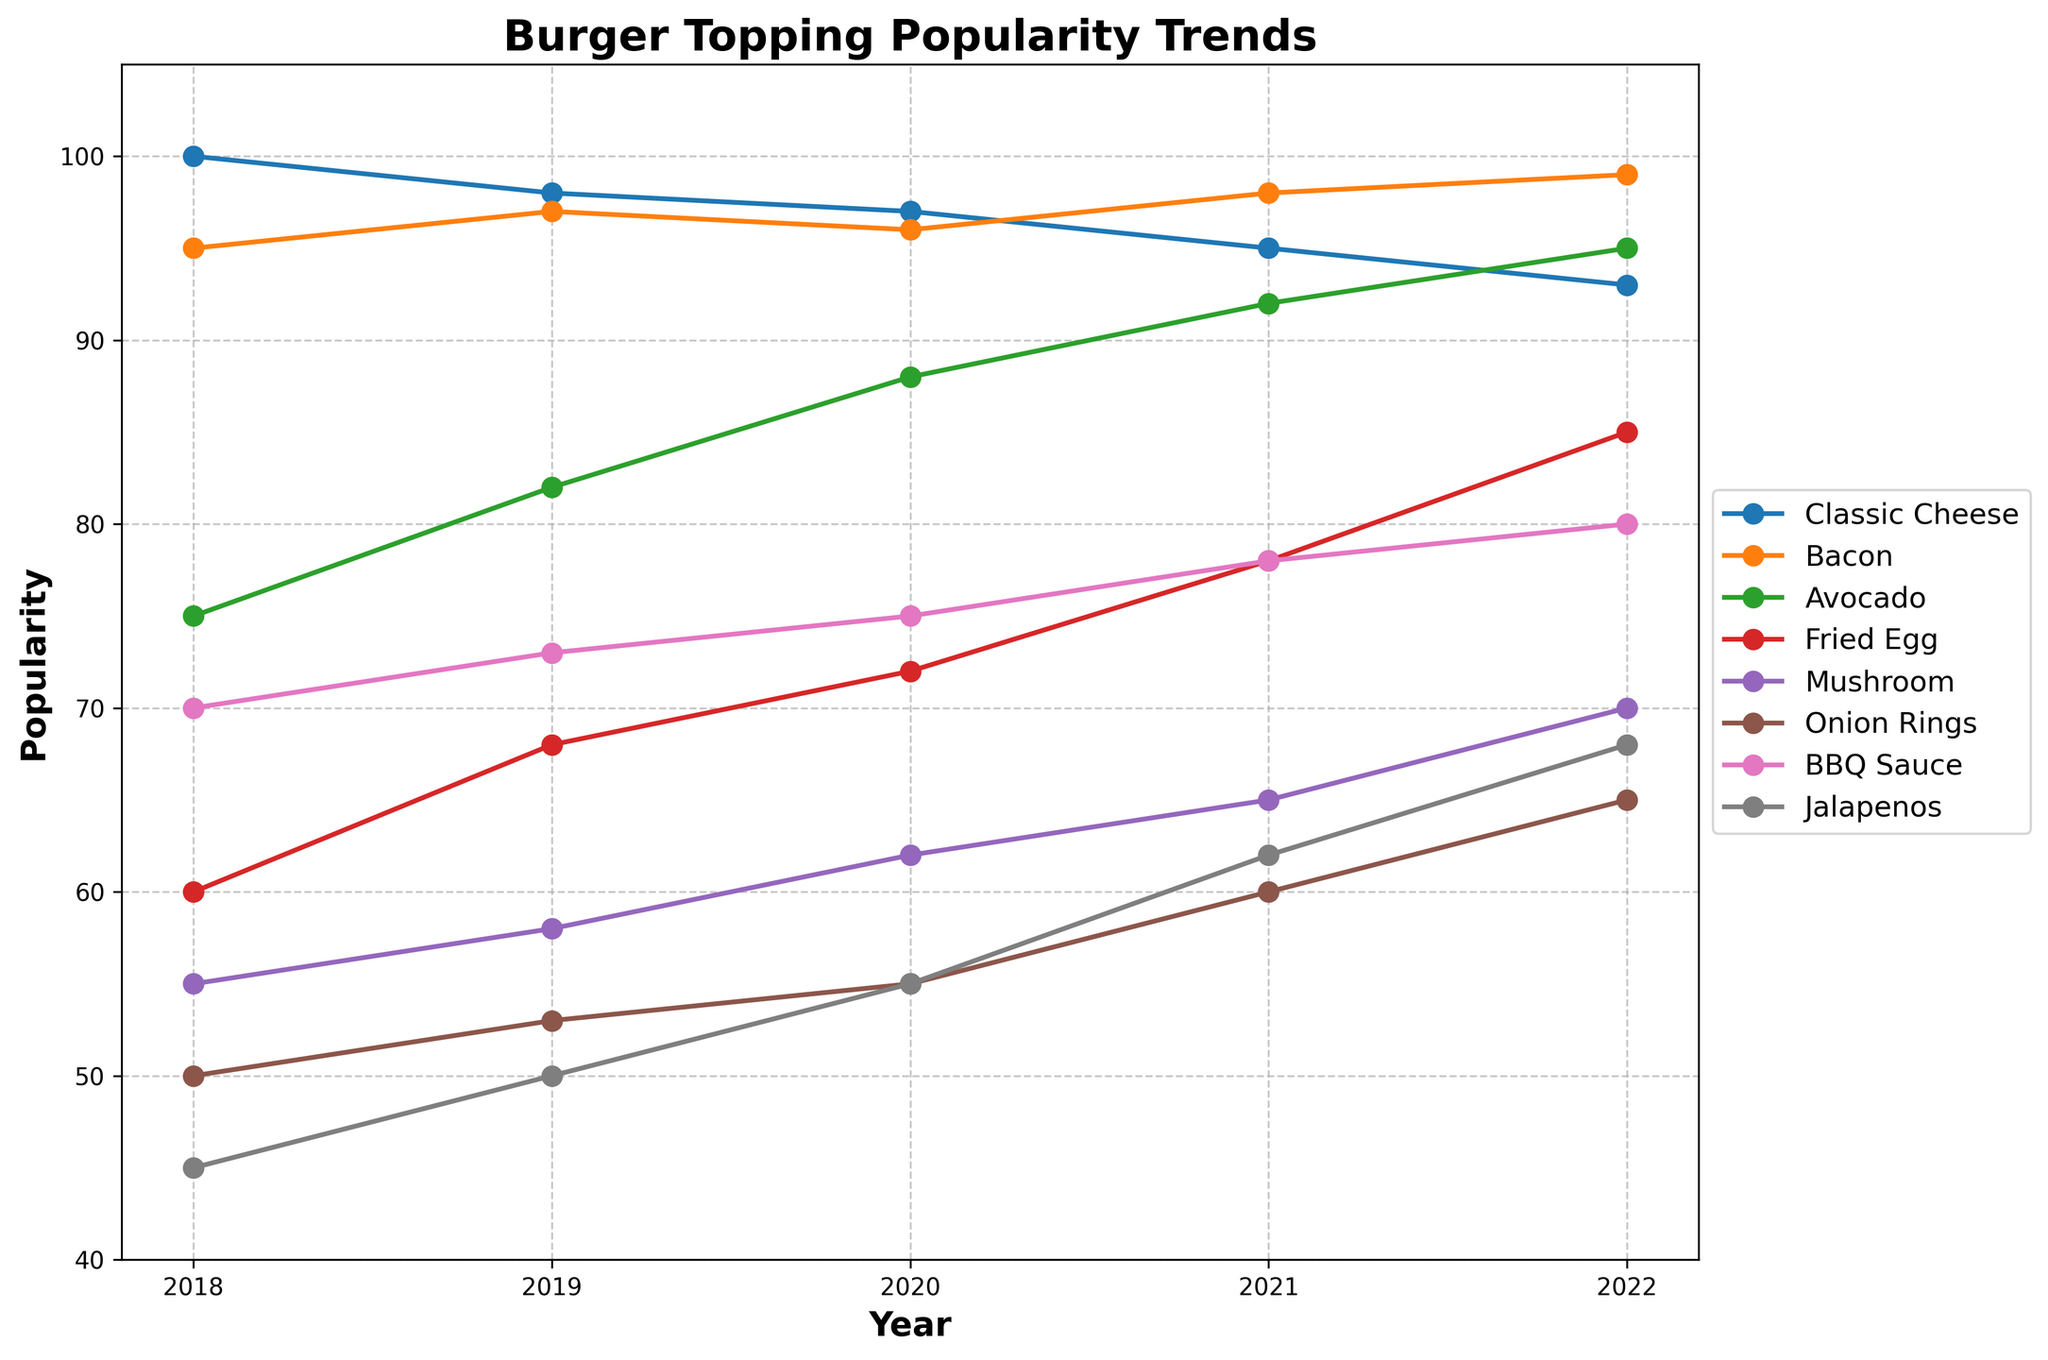What is the trend for the popularity of Avocado from 2018 to 2022? The Avocado topping's popularity increases steadily from 75 in 2018 to 95 in 2022. To verify, observe the line representing Avocado rising consistently.
Answer: Steadily increasing Which year did Onion Rings overtake Fried Egg in popularity? Compare the values for Onion Rings and Fried Egg year by year. In 2021, Onion Rings (60) surpass Fried Egg (78).
Answer: 2021 Between 2020 and 2021, which topping had the greatest increase in popularity? Calculate the difference in popularity between 2020 and 2021 for each topping. Classic Cheese: -2, Bacon: 2, Avocado: 4, Fried Egg: 6, Mushroom: 3, Onion Rings: 5, BBQ Sauce: 3, Jalapenos: 7. Jalapenos have the greatest increase (55 to 62).
Answer: Jalapenos What is the average popularity of BBQ Sauce over the 5-year period? Add the values for BBQ Sauce from 2018 to 2022 and divide by the number of years: (70 + 73 + 75 + 78 + 80) / 5 = 75.2.
Answer: 75.2 Compare the popularity trend lines for Classic Cheese and Bacon. Which topping is more popular overall, and by how much? Sum the popularity values over the years for Classic Cheese (100+98+97+95+93=483) and for Bacon (95+97+96+98+99=485). Bacon is more popular by 2 points overall.
Answer: Bacon by 2 In 2022, which topping saw the largest increase compared to the previous year? Subtract the 2021 values from the 2022 values: Classic Cheese: -2, Bacon: 1, Avocado: 3, Fried Egg: 7, Mushroom: 5, Onion Rings: 5, BBQ Sauce: 2, Jalapenos: 6. Fried Egg saw the largest increase (7 points).
Answer: Fried Egg On which year did Classic Cheese see its smallest decline in popularity? Observe the yearly changes for Classic Cheese: 2018-2019: -2, 2019-2020: -1, 2020-2021: -2, 2021-2022: -2. The smallest decline occurred between 2019 and 2020.
Answer: 2019-2020 What is the overall trend for Mushroom's popularity? Analyze the Mushroom values from 2018 to 2022 (55, 58, 62, 65, 70). The trend shows a steady increase over the years.
Answer: Steadily increasing How does the popularity of Fried Egg in 2022 compare to its initial value in 2018? Compare the values of Fried Egg in 2018 (60) and 2022 (85). The popularity has increased by 25 points.
Answer: Increased by 25 In terms of visual attributes, which topping has the most fluctuating line in the plot? Visually inspect the plotted lines. The Classic Cheese line fluctuates the most between years compared to others, indicating more variable popularity.
Answer: Classic Cheese 